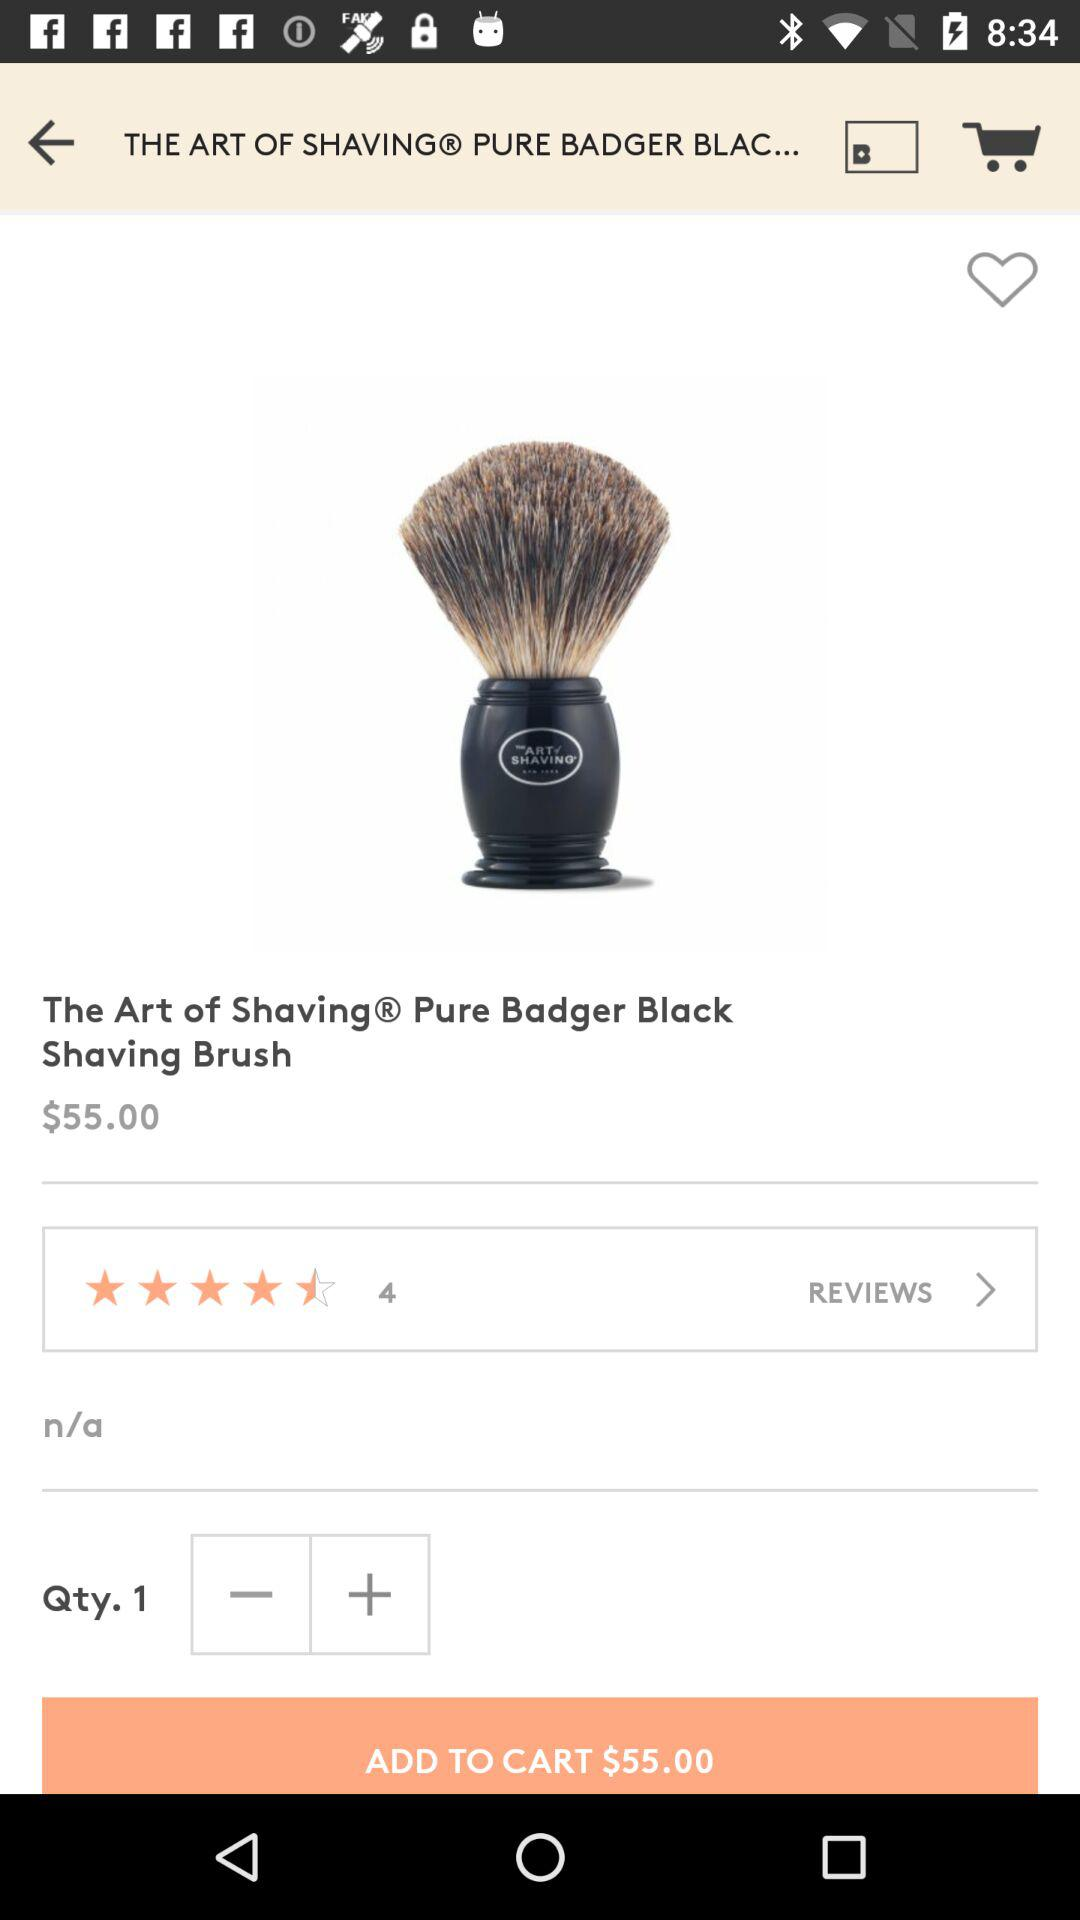What is the price for a pure badger black shaving brush? The price is $55.00. 